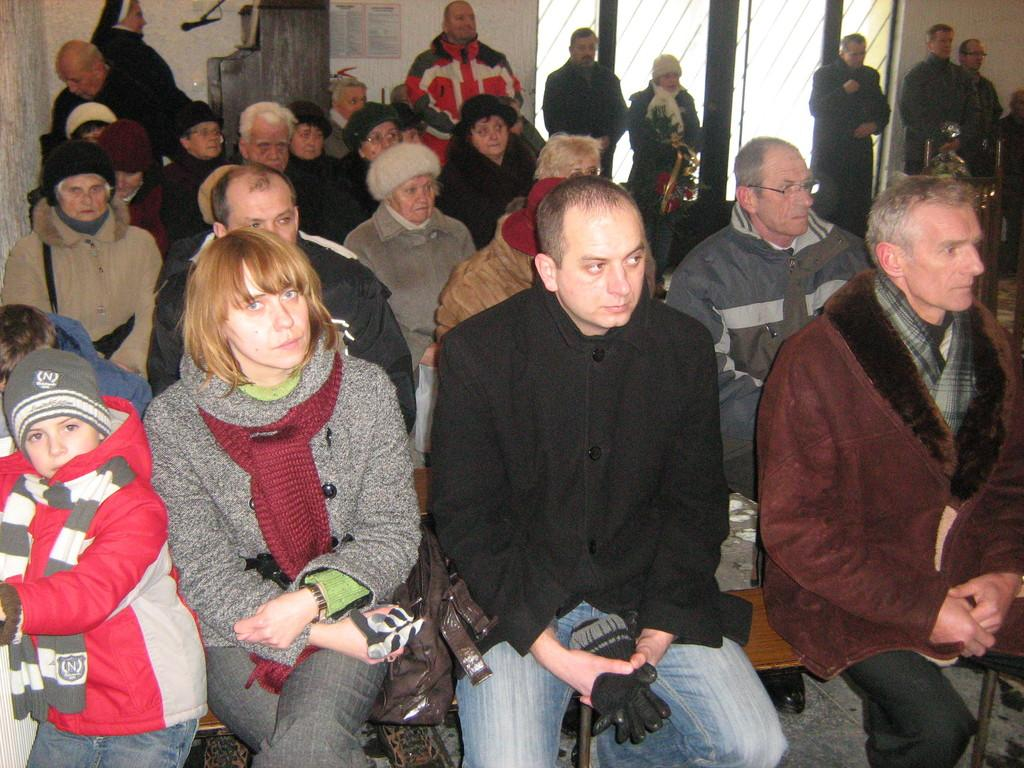How many people are in the image? There is a group of people in the image. What are some of the people in the image doing? Some people are sitting on chairs, while others are standing. What can be seen in the background of the image? There is a microphone and a poster on the wall in the background of the image. What is the value of the thought process depicted in the image? There is no thought process depicted in the image, as it only shows a group of people with some sitting and standing, along with a microphone and a poster on the wall in the background. 